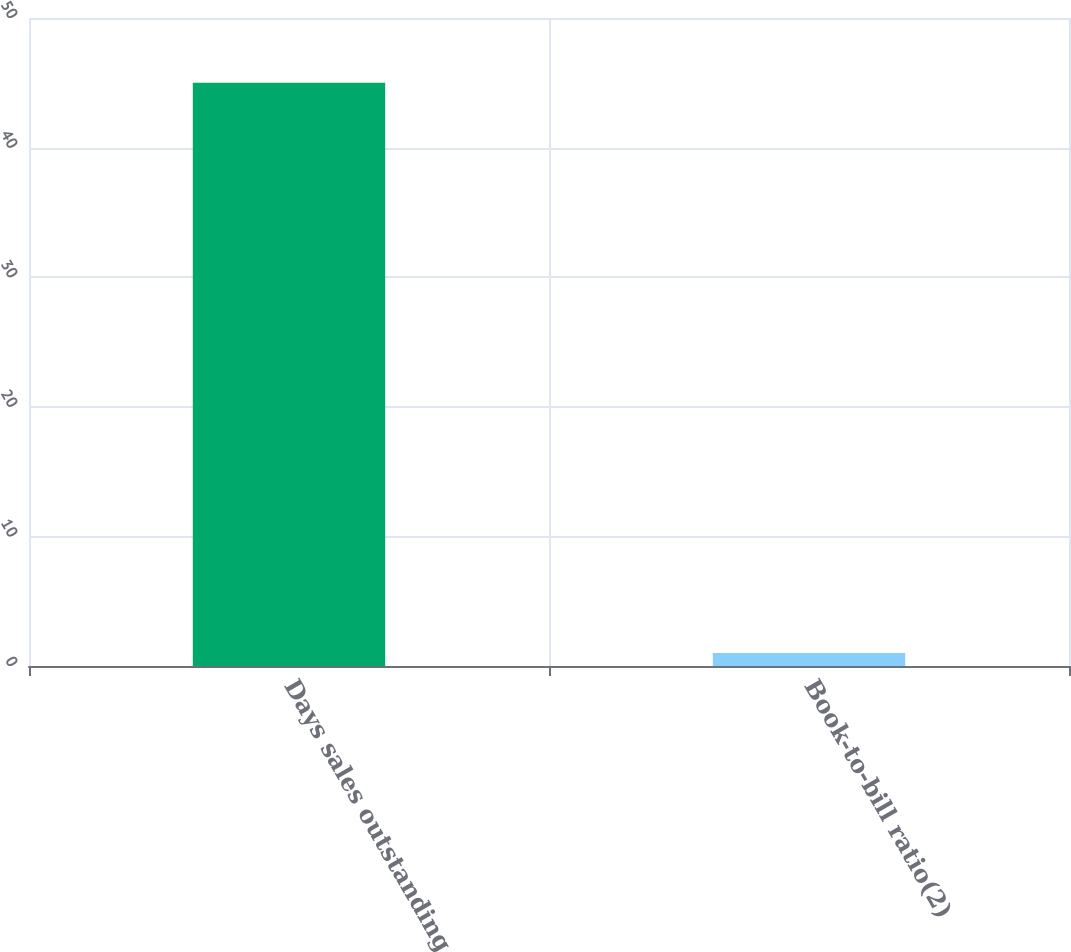Convert chart. <chart><loc_0><loc_0><loc_500><loc_500><bar_chart><fcel>Days sales outstanding<fcel>Book-to-bill ratio(2)<nl><fcel>45<fcel>1<nl></chart> 